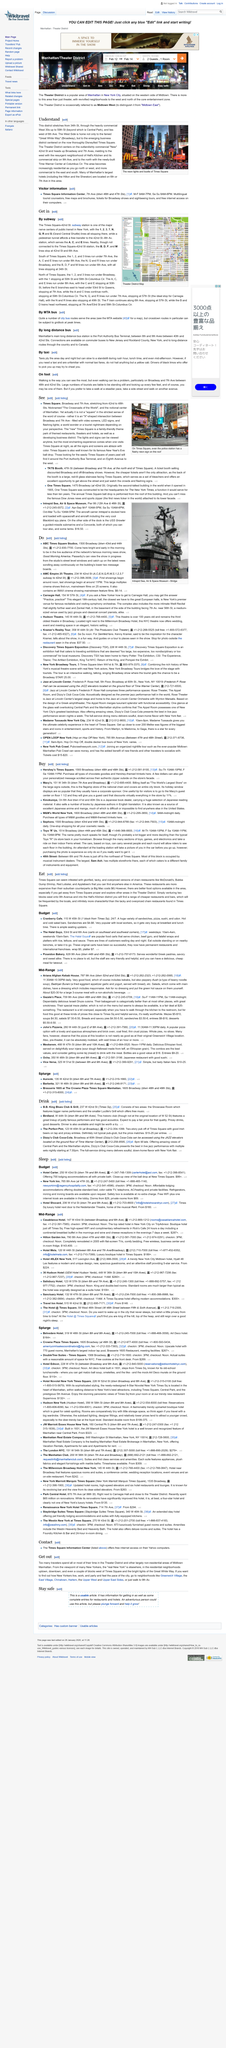Indicate a few pertinent items in this graphic. The page 'Eat' is dedicated to the topic of food and its related subjects. It is reported that the police station located at the approximate center of Manhattan has a flashy neon sign on its rooftop. At peak times, MTA buses can experience gridlock. The Times Square district is located in Manhattan, stretching from 34th Street through the West 30s and up to 59th Street. It is situated west of Sixth Avenue. The Port Authority Bus Terminal is the main long distance bus station in Manhattan. It serves as a hub for buses traveling to and from various destinations across the United States. Many people rely on the Port Authority Bus Terminal for their transportation needs, as it offers convenient access to and from the heart of the city. Whether traveling for business or pleasure, the Port Authority Bus Terminal is a reliable and cost-effective option for reaching your destination. 